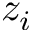Convert formula to latex. <formula><loc_0><loc_0><loc_500><loc_500>z _ { i }</formula> 